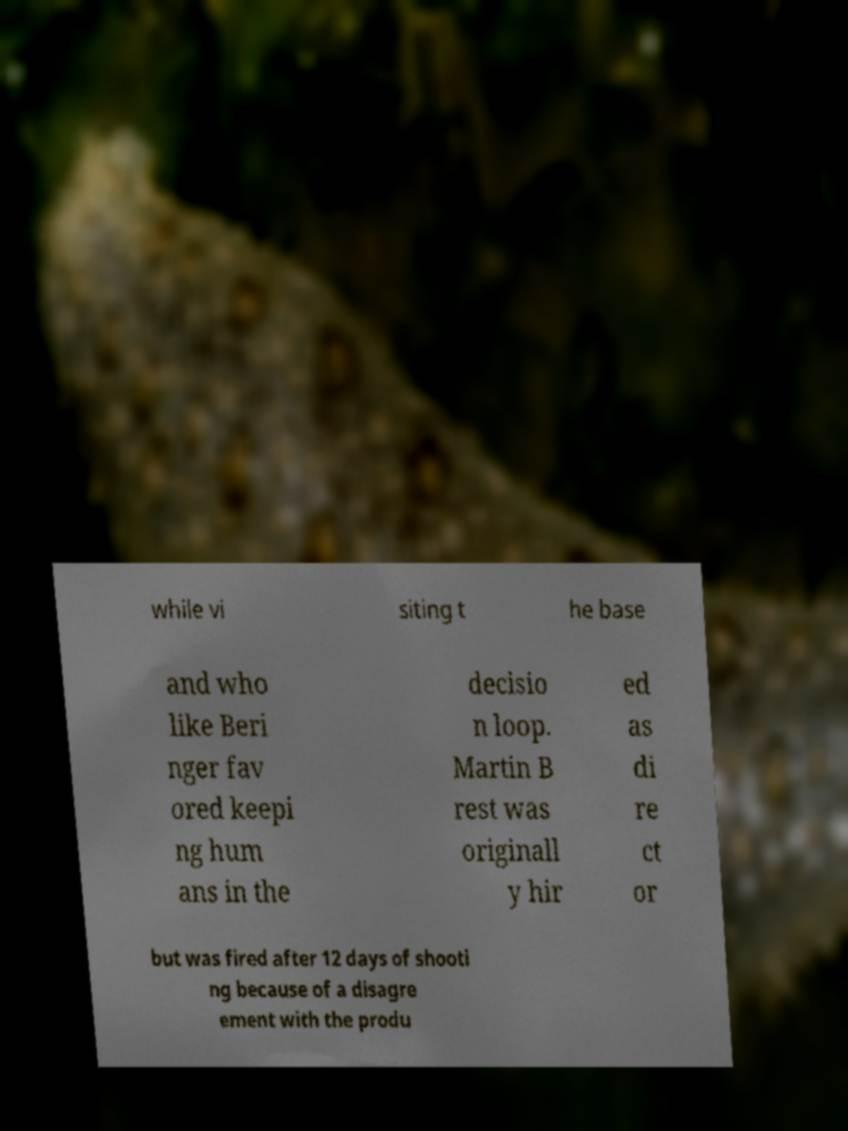Can you read and provide the text displayed in the image?This photo seems to have some interesting text. Can you extract and type it out for me? while vi siting t he base and who like Beri nger fav ored keepi ng hum ans in the decisio n loop. Martin B rest was originall y hir ed as di re ct or but was fired after 12 days of shooti ng because of a disagre ement with the produ 